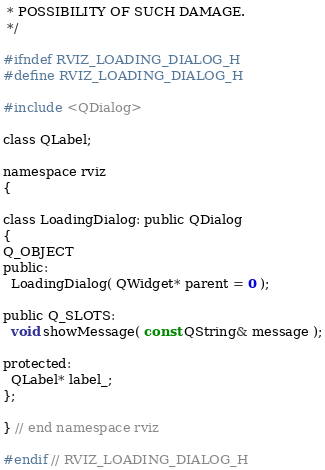<code> <loc_0><loc_0><loc_500><loc_500><_C_> * POSSIBILITY OF SUCH DAMAGE.
 */

#ifndef RVIZ_LOADING_DIALOG_H
#define RVIZ_LOADING_DIALOG_H

#include <QDialog>

class QLabel;

namespace rviz
{

class LoadingDialog: public QDialog
{
Q_OBJECT
public:
  LoadingDialog( QWidget* parent = 0 );

public Q_SLOTS:
  void showMessage( const QString& message );

protected:
  QLabel* label_;
};

} // end namespace rviz

#endif // RVIZ_LOADING_DIALOG_H
</code> 